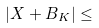Convert formula to latex. <formula><loc_0><loc_0><loc_500><loc_500>| X + B _ { K } | \leq</formula> 